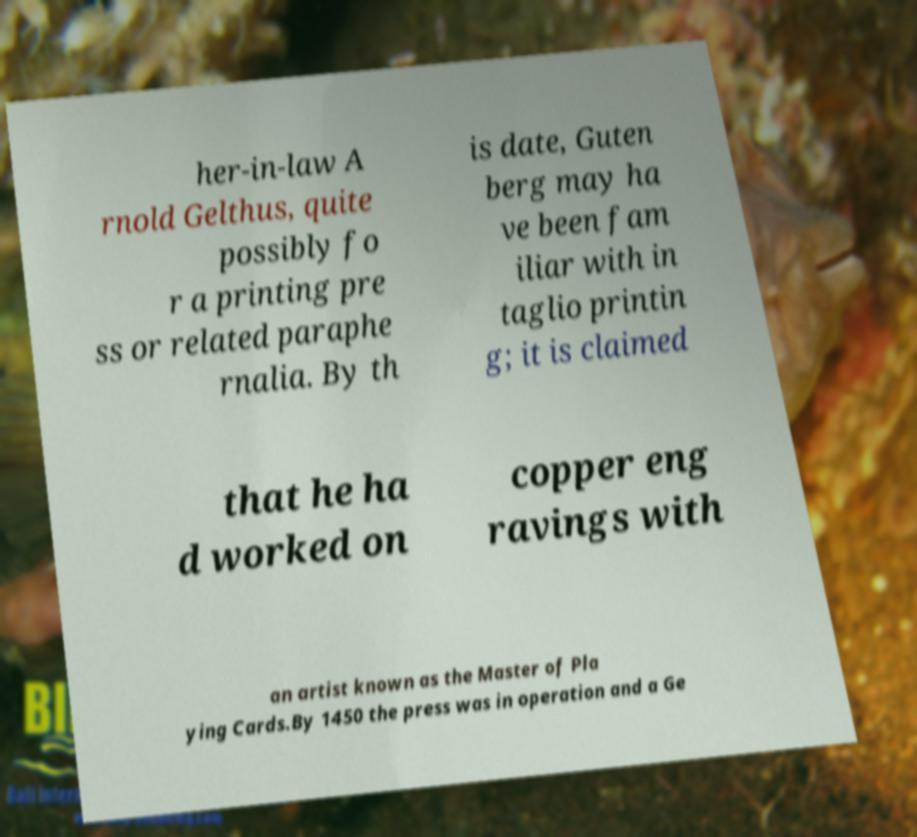For documentation purposes, I need the text within this image transcribed. Could you provide that? her-in-law A rnold Gelthus, quite possibly fo r a printing pre ss or related paraphe rnalia. By th is date, Guten berg may ha ve been fam iliar with in taglio printin g; it is claimed that he ha d worked on copper eng ravings with an artist known as the Master of Pla ying Cards.By 1450 the press was in operation and a Ge 